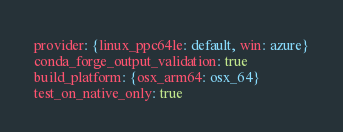Convert code to text. <code><loc_0><loc_0><loc_500><loc_500><_YAML_>provider: {linux_ppc64le: default, win: azure}
conda_forge_output_validation: true
build_platform: {osx_arm64: osx_64}
test_on_native_only: true
</code> 